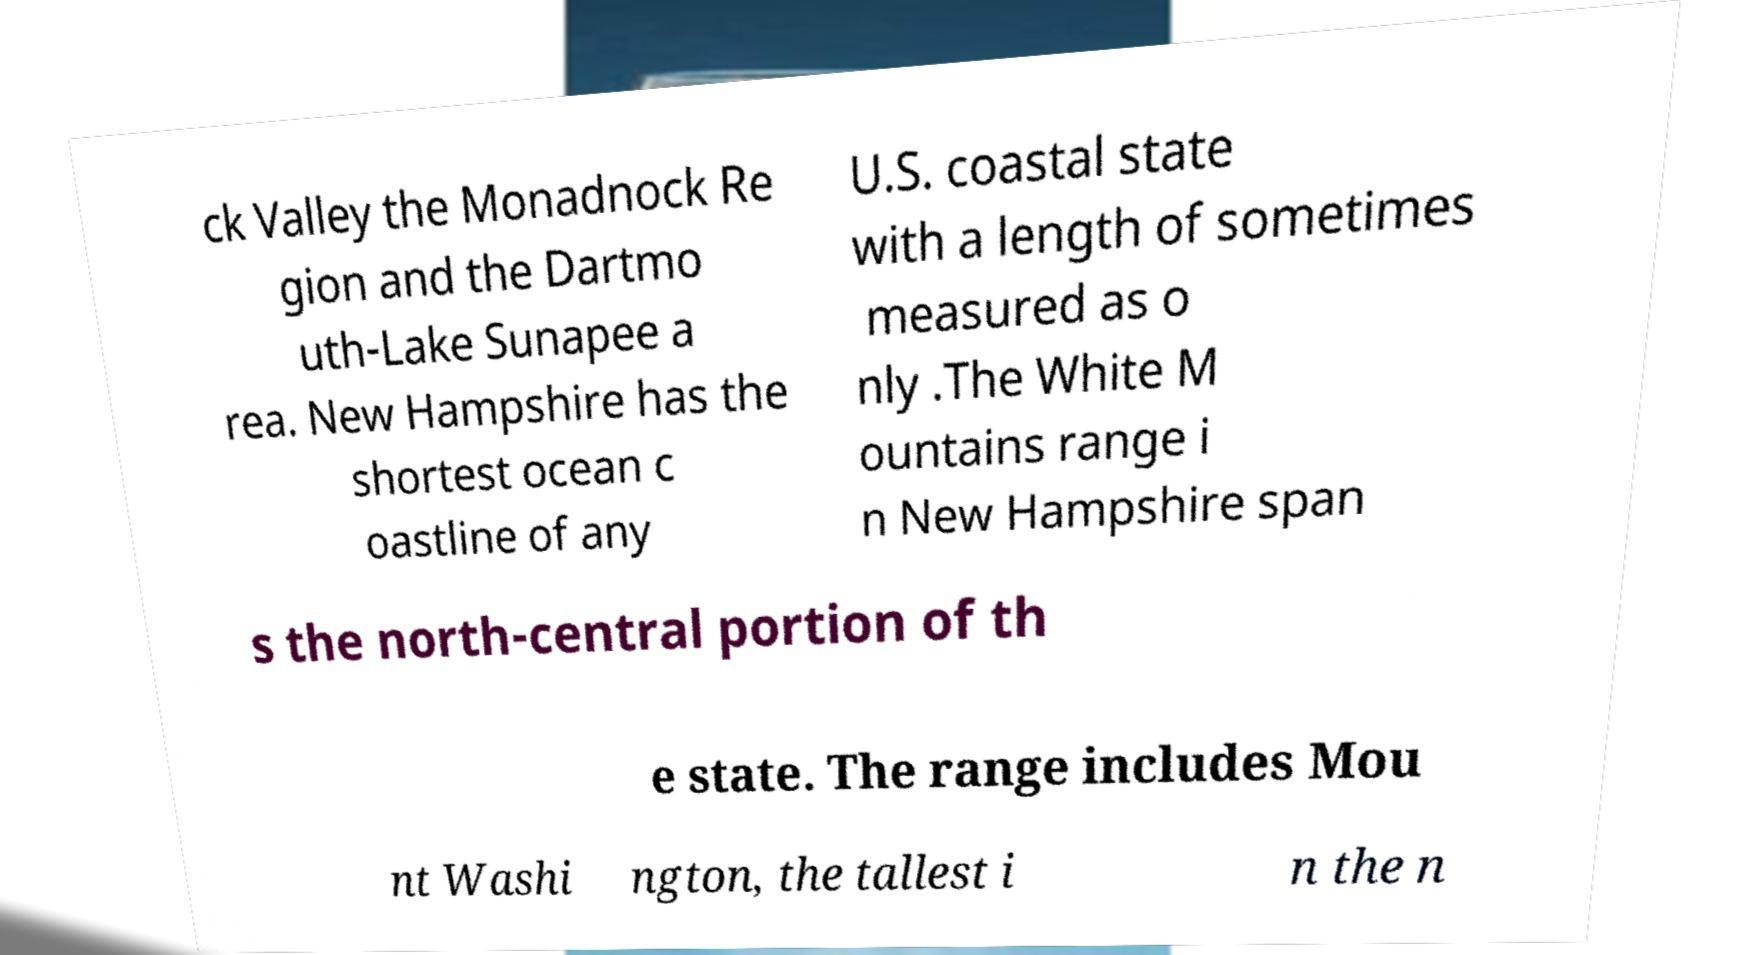Could you assist in decoding the text presented in this image and type it out clearly? ck Valley the Monadnock Re gion and the Dartmo uth-Lake Sunapee a rea. New Hampshire has the shortest ocean c oastline of any U.S. coastal state with a length of sometimes measured as o nly .The White M ountains range i n New Hampshire span s the north-central portion of th e state. The range includes Mou nt Washi ngton, the tallest i n the n 